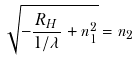<formula> <loc_0><loc_0><loc_500><loc_500>\sqrt { - \frac { R _ { H } } { 1 / \lambda } + n _ { 1 } ^ { 2 } } = n _ { 2 }</formula> 